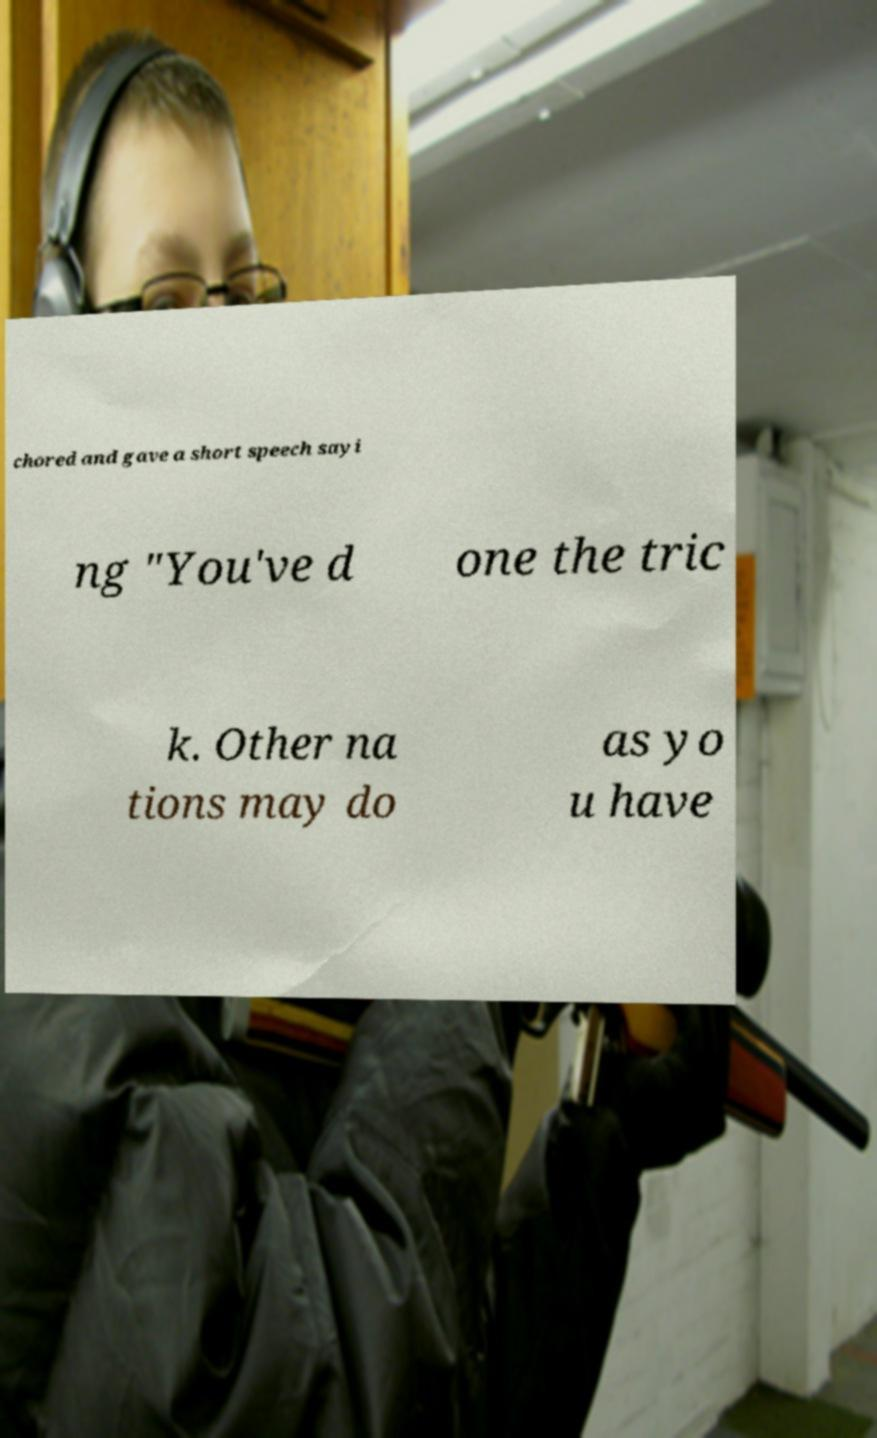Could you extract and type out the text from this image? chored and gave a short speech sayi ng "You've d one the tric k. Other na tions may do as yo u have 